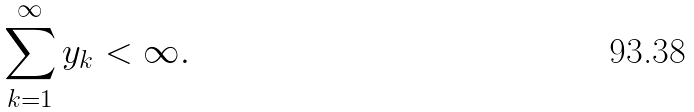Convert formula to latex. <formula><loc_0><loc_0><loc_500><loc_500>\sum _ { k = 1 } ^ { \infty } y _ { k } < \infty .</formula> 